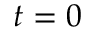<formula> <loc_0><loc_0><loc_500><loc_500>t = 0</formula> 